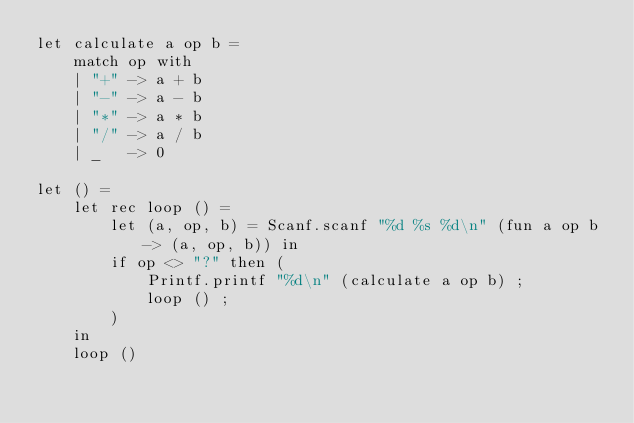<code> <loc_0><loc_0><loc_500><loc_500><_OCaml_>let calculate a op b =
    match op with
    | "+" -> a + b
    | "-" -> a - b
    | "*" -> a * b
    | "/" -> a / b
    | _   -> 0

let () =
    let rec loop () =
        let (a, op, b) = Scanf.scanf "%d %s %d\n" (fun a op b -> (a, op, b)) in
        if op <> "?" then (
            Printf.printf "%d\n" (calculate a op b) ;
            loop () ;
        )
    in
    loop ()</code> 